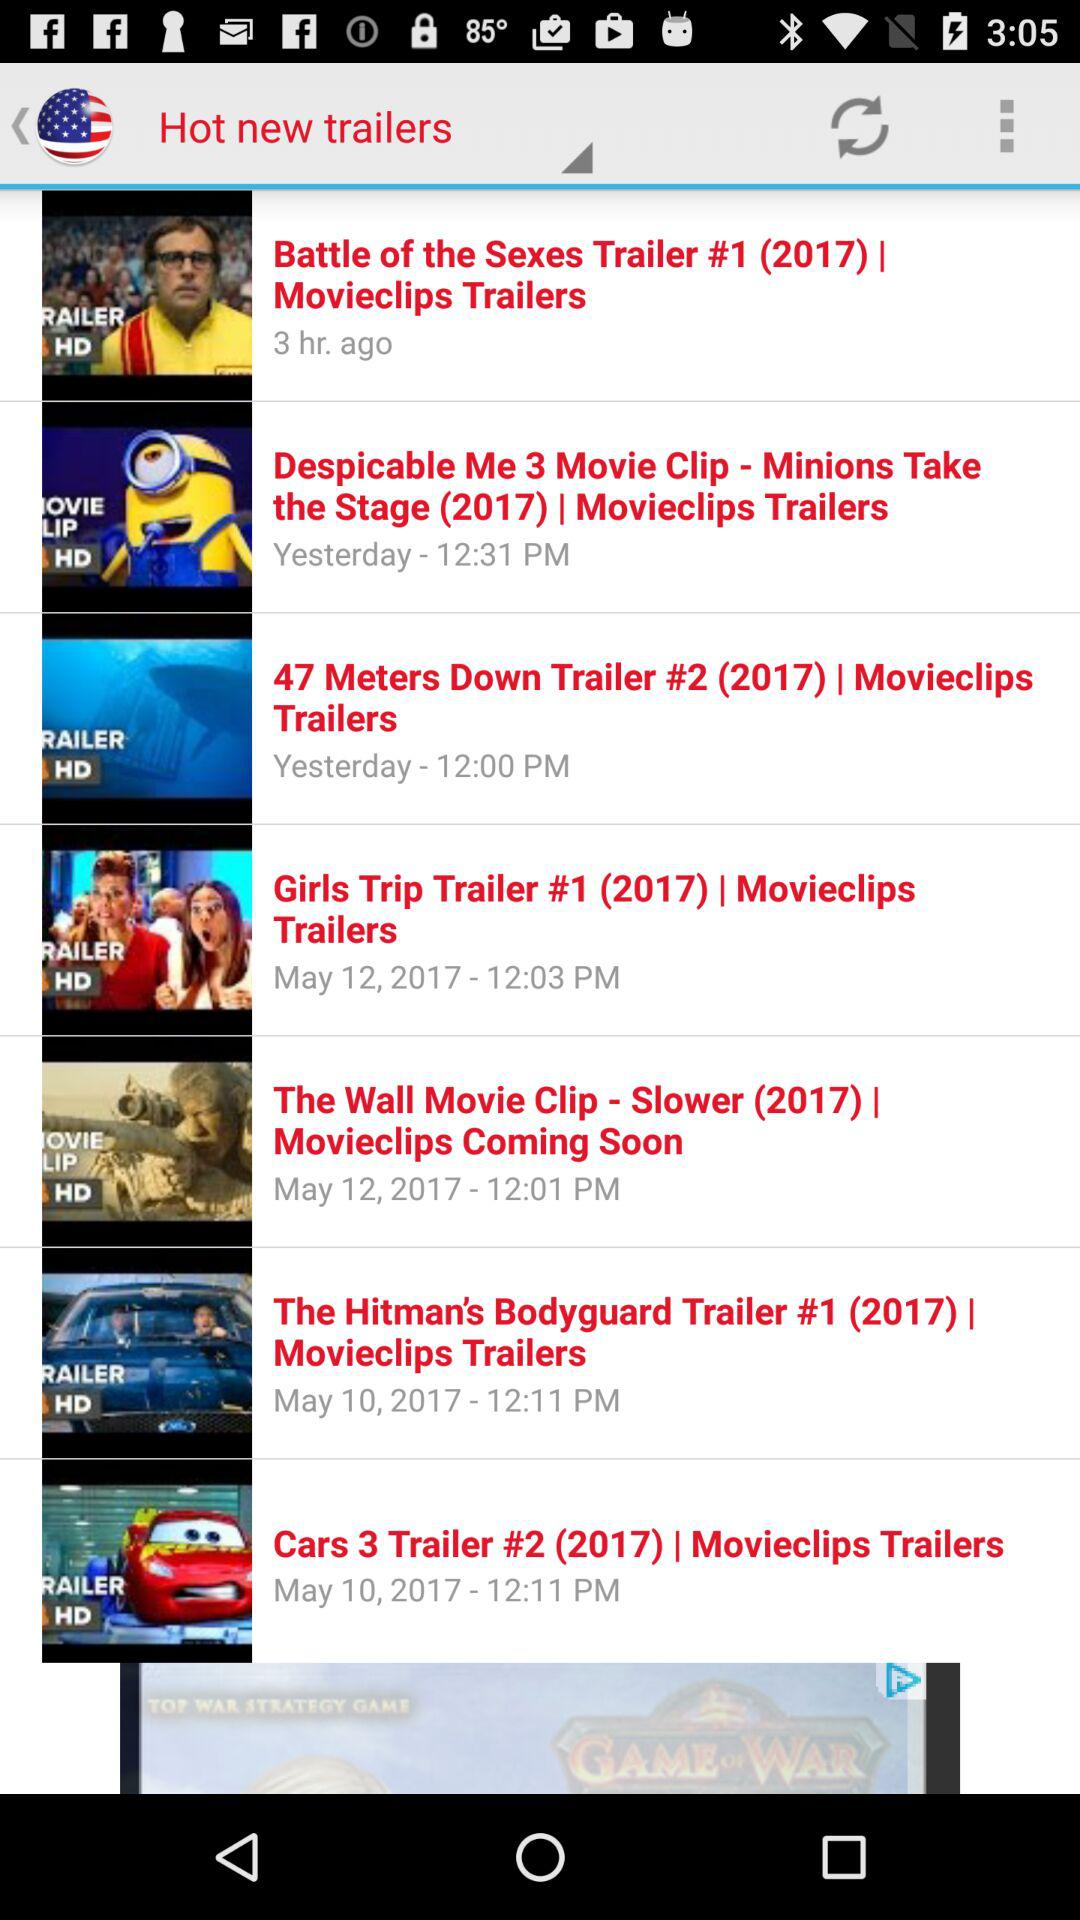Which movie trailers were posted yesterday? The movie trailers were "Despicable Me 3" and "47 Meters Down". 